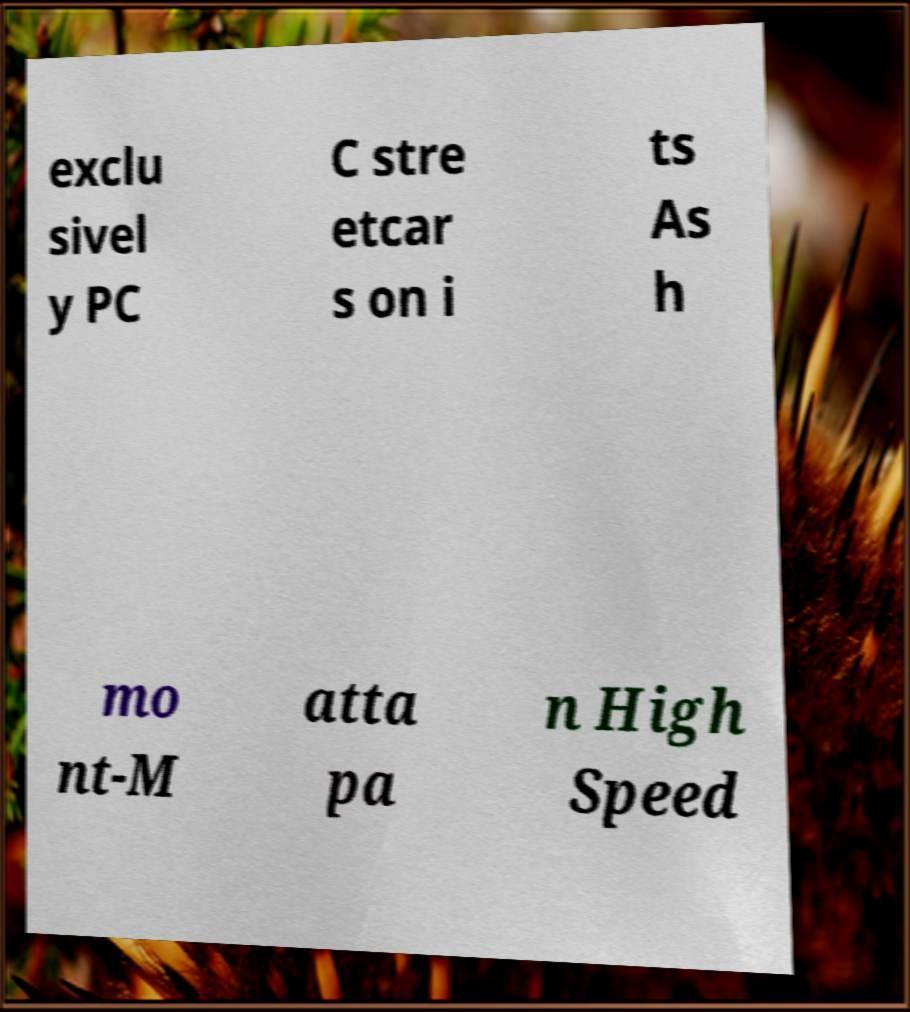Could you extract and type out the text from this image? exclu sivel y PC C stre etcar s on i ts As h mo nt-M atta pa n High Speed 